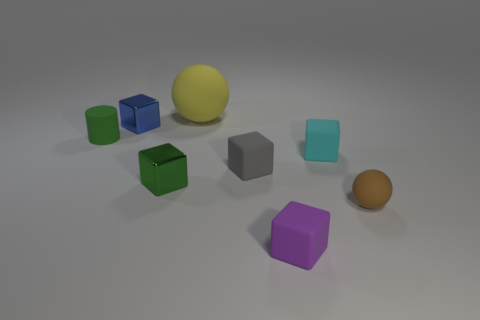Are there any green things in front of the gray object?
Give a very brief answer. Yes. There is a yellow thing behind the matte thing that is in front of the small ball; what shape is it?
Provide a short and direct response. Sphere. Are there fewer yellow spheres that are on the right side of the gray matte cube than things to the right of the big yellow thing?
Your answer should be very brief. Yes. The large thing that is the same shape as the small brown matte object is what color?
Your answer should be very brief. Yellow. How many tiny things are both behind the rubber cylinder and to the right of the tiny green block?
Provide a short and direct response. 0. Are there more metallic things that are right of the purple object than brown things that are to the left of the yellow sphere?
Make the answer very short. No. What size is the cyan thing?
Your response must be concise. Small. Are there any large gray metal things that have the same shape as the purple rubber thing?
Offer a very short reply. No. There is a tiny gray matte object; is its shape the same as the rubber object on the left side of the yellow rubber object?
Provide a succinct answer. No. How big is the thing that is both in front of the yellow thing and behind the small green rubber object?
Offer a terse response. Small. 